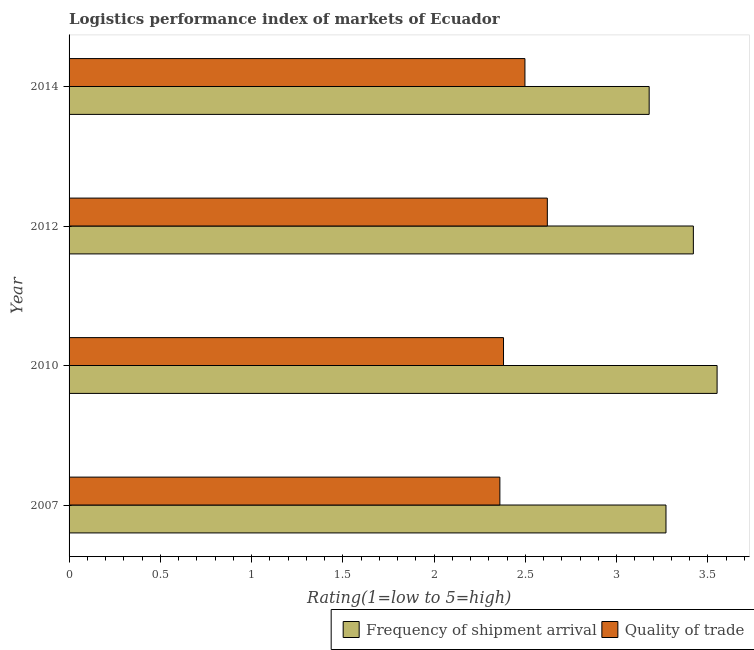How many different coloured bars are there?
Keep it short and to the point. 2. Are the number of bars per tick equal to the number of legend labels?
Provide a short and direct response. Yes. Are the number of bars on each tick of the Y-axis equal?
Your response must be concise. Yes. How many bars are there on the 1st tick from the bottom?
Ensure brevity in your answer.  2. What is the label of the 4th group of bars from the top?
Your answer should be compact. 2007. What is the lpi quality of trade in 2014?
Provide a succinct answer. 2.5. Across all years, what is the maximum lpi quality of trade?
Offer a very short reply. 2.62. Across all years, what is the minimum lpi of frequency of shipment arrival?
Offer a very short reply. 3.18. In which year was the lpi quality of trade maximum?
Offer a terse response. 2012. What is the total lpi quality of trade in the graph?
Your answer should be very brief. 9.86. What is the difference between the lpi quality of trade in 2010 and that in 2012?
Provide a short and direct response. -0.24. What is the difference between the lpi of frequency of shipment arrival in 2010 and the lpi quality of trade in 2007?
Provide a succinct answer. 1.19. What is the average lpi quality of trade per year?
Provide a short and direct response. 2.46. In the year 2010, what is the difference between the lpi of frequency of shipment arrival and lpi quality of trade?
Ensure brevity in your answer.  1.17. In how many years, is the lpi quality of trade greater than 1.6 ?
Make the answer very short. 4. What is the ratio of the lpi of frequency of shipment arrival in 2007 to that in 2012?
Your answer should be very brief. 0.96. Is the lpi quality of trade in 2010 less than that in 2012?
Offer a terse response. Yes. Is the difference between the lpi of frequency of shipment arrival in 2010 and 2012 greater than the difference between the lpi quality of trade in 2010 and 2012?
Give a very brief answer. Yes. What is the difference between the highest and the second highest lpi quality of trade?
Ensure brevity in your answer.  0.12. What is the difference between the highest and the lowest lpi quality of trade?
Make the answer very short. 0.26. What does the 2nd bar from the top in 2010 represents?
Ensure brevity in your answer.  Frequency of shipment arrival. What does the 1st bar from the bottom in 2007 represents?
Offer a very short reply. Frequency of shipment arrival. Are all the bars in the graph horizontal?
Keep it short and to the point. Yes. What is the difference between two consecutive major ticks on the X-axis?
Provide a succinct answer. 0.5. Are the values on the major ticks of X-axis written in scientific E-notation?
Offer a very short reply. No. Does the graph contain any zero values?
Offer a very short reply. No. How many legend labels are there?
Make the answer very short. 2. What is the title of the graph?
Keep it short and to the point. Logistics performance index of markets of Ecuador. Does "Primary" appear as one of the legend labels in the graph?
Provide a succinct answer. No. What is the label or title of the X-axis?
Your answer should be very brief. Rating(1=low to 5=high). What is the Rating(1=low to 5=high) of Frequency of shipment arrival in 2007?
Your answer should be very brief. 3.27. What is the Rating(1=low to 5=high) of Quality of trade in 2007?
Ensure brevity in your answer.  2.36. What is the Rating(1=low to 5=high) of Frequency of shipment arrival in 2010?
Your response must be concise. 3.55. What is the Rating(1=low to 5=high) of Quality of trade in 2010?
Keep it short and to the point. 2.38. What is the Rating(1=low to 5=high) of Frequency of shipment arrival in 2012?
Your response must be concise. 3.42. What is the Rating(1=low to 5=high) in Quality of trade in 2012?
Give a very brief answer. 2.62. What is the Rating(1=low to 5=high) in Frequency of shipment arrival in 2014?
Make the answer very short. 3.18. What is the Rating(1=low to 5=high) of Quality of trade in 2014?
Ensure brevity in your answer.  2.5. Across all years, what is the maximum Rating(1=low to 5=high) of Frequency of shipment arrival?
Ensure brevity in your answer.  3.55. Across all years, what is the maximum Rating(1=low to 5=high) in Quality of trade?
Offer a very short reply. 2.62. Across all years, what is the minimum Rating(1=low to 5=high) in Frequency of shipment arrival?
Keep it short and to the point. 3.18. Across all years, what is the minimum Rating(1=low to 5=high) in Quality of trade?
Your answer should be compact. 2.36. What is the total Rating(1=low to 5=high) in Frequency of shipment arrival in the graph?
Keep it short and to the point. 13.42. What is the total Rating(1=low to 5=high) in Quality of trade in the graph?
Ensure brevity in your answer.  9.86. What is the difference between the Rating(1=low to 5=high) in Frequency of shipment arrival in 2007 and that in 2010?
Your response must be concise. -0.28. What is the difference between the Rating(1=low to 5=high) of Quality of trade in 2007 and that in 2010?
Your answer should be very brief. -0.02. What is the difference between the Rating(1=low to 5=high) of Quality of trade in 2007 and that in 2012?
Provide a succinct answer. -0.26. What is the difference between the Rating(1=low to 5=high) of Frequency of shipment arrival in 2007 and that in 2014?
Your answer should be compact. 0.09. What is the difference between the Rating(1=low to 5=high) of Quality of trade in 2007 and that in 2014?
Offer a very short reply. -0.14. What is the difference between the Rating(1=low to 5=high) of Frequency of shipment arrival in 2010 and that in 2012?
Provide a succinct answer. 0.13. What is the difference between the Rating(1=low to 5=high) of Quality of trade in 2010 and that in 2012?
Offer a very short reply. -0.24. What is the difference between the Rating(1=low to 5=high) in Frequency of shipment arrival in 2010 and that in 2014?
Your response must be concise. 0.37. What is the difference between the Rating(1=low to 5=high) of Quality of trade in 2010 and that in 2014?
Ensure brevity in your answer.  -0.12. What is the difference between the Rating(1=low to 5=high) of Frequency of shipment arrival in 2012 and that in 2014?
Your answer should be compact. 0.24. What is the difference between the Rating(1=low to 5=high) of Quality of trade in 2012 and that in 2014?
Offer a terse response. 0.12. What is the difference between the Rating(1=low to 5=high) in Frequency of shipment arrival in 2007 and the Rating(1=low to 5=high) in Quality of trade in 2010?
Your response must be concise. 0.89. What is the difference between the Rating(1=low to 5=high) in Frequency of shipment arrival in 2007 and the Rating(1=low to 5=high) in Quality of trade in 2012?
Your answer should be very brief. 0.65. What is the difference between the Rating(1=low to 5=high) in Frequency of shipment arrival in 2007 and the Rating(1=low to 5=high) in Quality of trade in 2014?
Give a very brief answer. 0.77. What is the difference between the Rating(1=low to 5=high) of Frequency of shipment arrival in 2010 and the Rating(1=low to 5=high) of Quality of trade in 2012?
Ensure brevity in your answer.  0.93. What is the difference between the Rating(1=low to 5=high) of Frequency of shipment arrival in 2010 and the Rating(1=low to 5=high) of Quality of trade in 2014?
Offer a very short reply. 1.05. What is the difference between the Rating(1=low to 5=high) of Frequency of shipment arrival in 2012 and the Rating(1=low to 5=high) of Quality of trade in 2014?
Offer a terse response. 0.92. What is the average Rating(1=low to 5=high) in Frequency of shipment arrival per year?
Your answer should be compact. 3.35. What is the average Rating(1=low to 5=high) of Quality of trade per year?
Keep it short and to the point. 2.46. In the year 2007, what is the difference between the Rating(1=low to 5=high) in Frequency of shipment arrival and Rating(1=low to 5=high) in Quality of trade?
Keep it short and to the point. 0.91. In the year 2010, what is the difference between the Rating(1=low to 5=high) in Frequency of shipment arrival and Rating(1=low to 5=high) in Quality of trade?
Your answer should be compact. 1.17. In the year 2012, what is the difference between the Rating(1=low to 5=high) in Frequency of shipment arrival and Rating(1=low to 5=high) in Quality of trade?
Offer a very short reply. 0.8. In the year 2014, what is the difference between the Rating(1=low to 5=high) of Frequency of shipment arrival and Rating(1=low to 5=high) of Quality of trade?
Give a very brief answer. 0.68. What is the ratio of the Rating(1=low to 5=high) of Frequency of shipment arrival in 2007 to that in 2010?
Provide a succinct answer. 0.92. What is the ratio of the Rating(1=low to 5=high) in Frequency of shipment arrival in 2007 to that in 2012?
Your response must be concise. 0.96. What is the ratio of the Rating(1=low to 5=high) of Quality of trade in 2007 to that in 2012?
Keep it short and to the point. 0.9. What is the ratio of the Rating(1=low to 5=high) of Frequency of shipment arrival in 2007 to that in 2014?
Offer a very short reply. 1.03. What is the ratio of the Rating(1=low to 5=high) of Quality of trade in 2007 to that in 2014?
Offer a very short reply. 0.94. What is the ratio of the Rating(1=low to 5=high) in Frequency of shipment arrival in 2010 to that in 2012?
Ensure brevity in your answer.  1.04. What is the ratio of the Rating(1=low to 5=high) in Quality of trade in 2010 to that in 2012?
Offer a very short reply. 0.91. What is the ratio of the Rating(1=low to 5=high) of Frequency of shipment arrival in 2010 to that in 2014?
Provide a short and direct response. 1.12. What is the ratio of the Rating(1=low to 5=high) in Quality of trade in 2010 to that in 2014?
Offer a terse response. 0.95. What is the ratio of the Rating(1=low to 5=high) of Frequency of shipment arrival in 2012 to that in 2014?
Provide a succinct answer. 1.08. What is the ratio of the Rating(1=low to 5=high) in Quality of trade in 2012 to that in 2014?
Offer a terse response. 1.05. What is the difference between the highest and the second highest Rating(1=low to 5=high) in Frequency of shipment arrival?
Your answer should be compact. 0.13. What is the difference between the highest and the second highest Rating(1=low to 5=high) in Quality of trade?
Keep it short and to the point. 0.12. What is the difference between the highest and the lowest Rating(1=low to 5=high) in Frequency of shipment arrival?
Your response must be concise. 0.37. What is the difference between the highest and the lowest Rating(1=low to 5=high) in Quality of trade?
Your answer should be very brief. 0.26. 